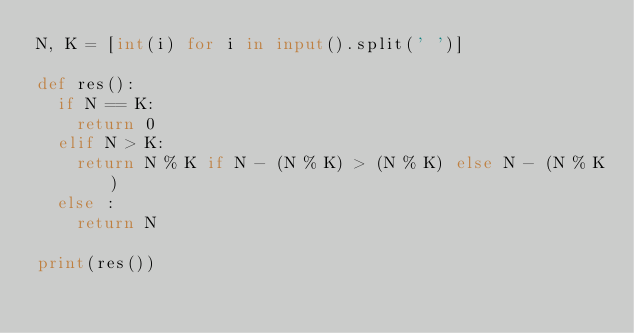Convert code to text. <code><loc_0><loc_0><loc_500><loc_500><_Python_>N, K = [int(i) for i in input().split(' ')]

def res():
  if N == K:
    return 0
  elif N > K:
    return N % K if N - (N % K) > (N % K) else N - (N % K)
  else :
    return N

print(res())</code> 